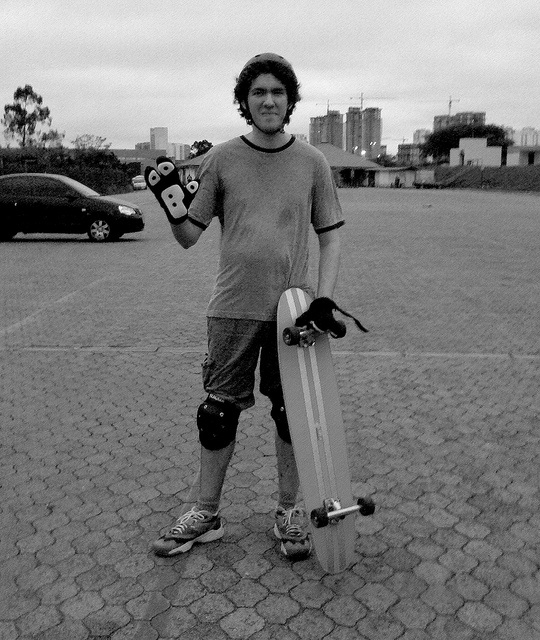Describe the objects in this image and their specific colors. I can see people in lightgray, gray, and black tones, skateboard in lightgray, gray, and black tones, car in lightgray, black, gray, and darkgray tones, and car in lightgray, darkgray, gray, and black tones in this image. 